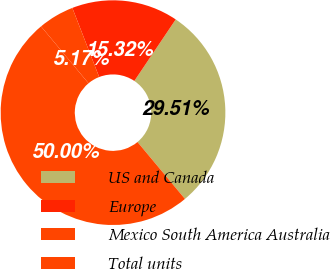Convert chart to OTSL. <chart><loc_0><loc_0><loc_500><loc_500><pie_chart><fcel>US and Canada<fcel>Europe<fcel>Mexico South America Australia<fcel>Total units<nl><fcel>29.51%<fcel>15.32%<fcel>5.17%<fcel>50.0%<nl></chart> 